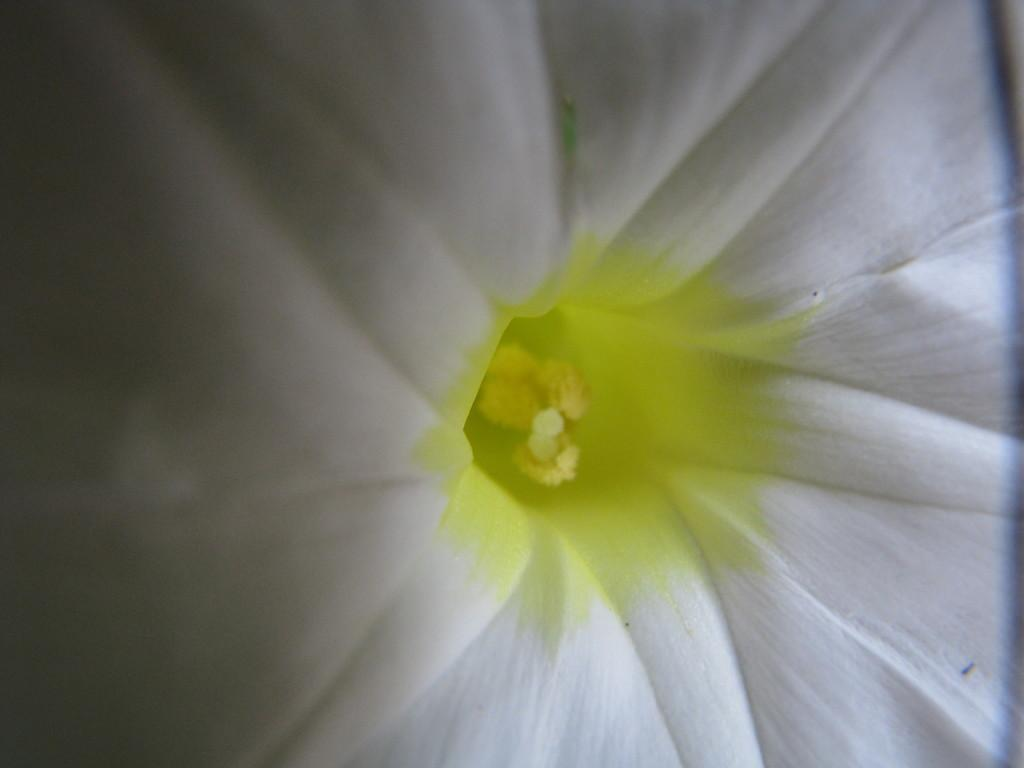What type of flower is present in the image? There is a white flower in the image. How many bears are visible in the image? There are no bears present in the image; it features a white flower. What is the name of the son in the image? There is no reference to a son in the image, as it only features a white flower. 